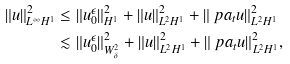<formula> <loc_0><loc_0><loc_500><loc_500>\| u \| _ { L ^ { \infty } H ^ { 1 } } ^ { 2 } & \leq \| u _ { 0 } ^ { \epsilon } \| _ { H ^ { 1 } } ^ { 2 } + \| u \| _ { L ^ { 2 } H ^ { 1 } } ^ { 2 } + \| \ p a _ { t } u \| _ { L ^ { 2 } H ^ { 1 } } ^ { 2 } \\ & \lesssim \| u _ { 0 } ^ { \epsilon } \| _ { W _ { \delta } ^ { 2 } } ^ { 2 } + \| u \| _ { L ^ { 2 } H ^ { 1 } } ^ { 2 } + \| \ p a _ { t } u \| _ { L ^ { 2 } H ^ { 1 } } ^ { 2 } ,</formula> 